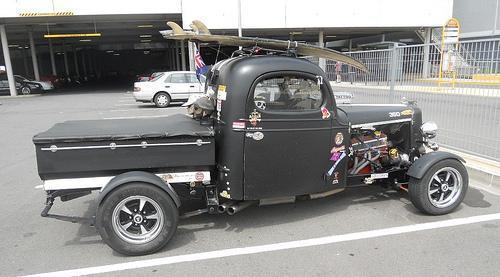How many black cars are there?
Give a very brief answer. 1. 